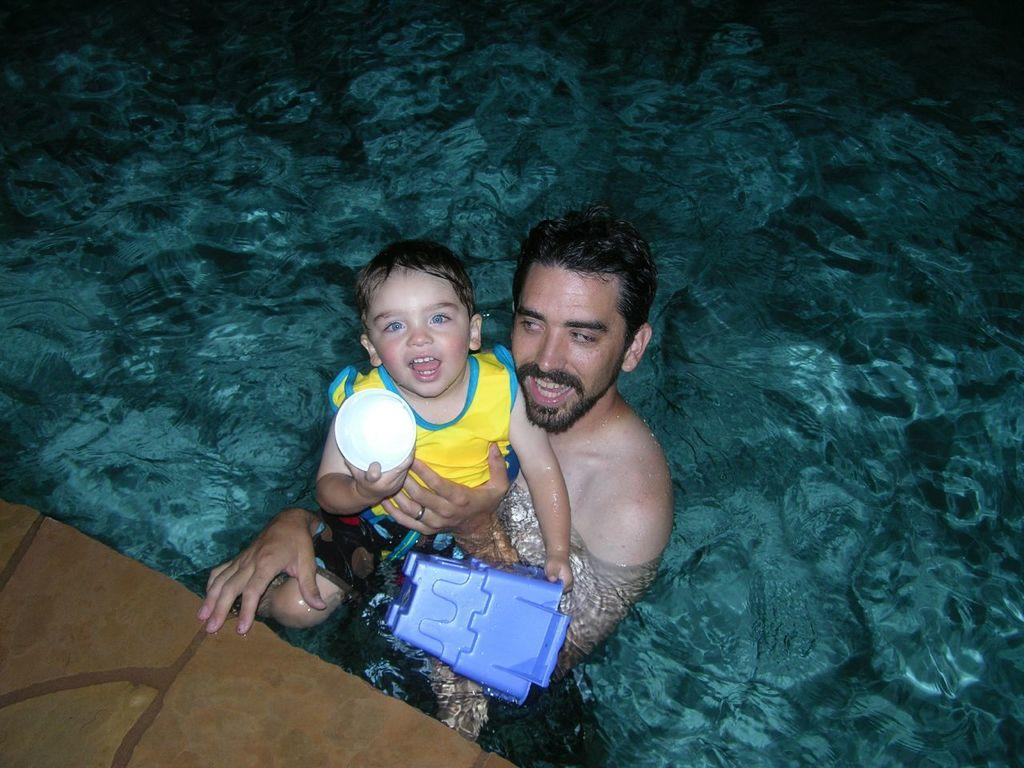Who is present in the image? There is a man in the image. What is the man doing in the image? The man is holding a child. What is the child doing in the image? The child is holding objects in their hands. Where are the man and the child located in the image? Both the man and the child are in the water. What type of cushion can be seen in the image? There is no cushion present in the image. What is the name of the town where the image was taken? The provided facts do not mention a town or location, so it cannot be determined from the image. 